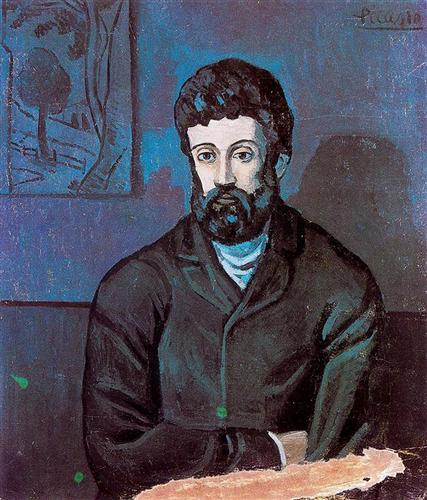Describe the following image.
 The image you've shared is a captivating piece of art. It's a portrait of a man, distinguished by his beard and mustache. He's dressed in a black jacket and a blue shirt, which stand out against the blue background. On the left side of the background, there's a sketch of a tree, adding an element of nature to the composition. The colors used in this painting are mainly blue, black, and green, creating a cool and calming palette. This artwork is in the post-impressionism style, a genre known for its emphasis on abstract qualities and symbolic content. The painting is signed by the artist, Picasso, on the top right corner, marking it as a product of his creative genius. 